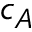<formula> <loc_0><loc_0><loc_500><loc_500>c _ { A }</formula> 